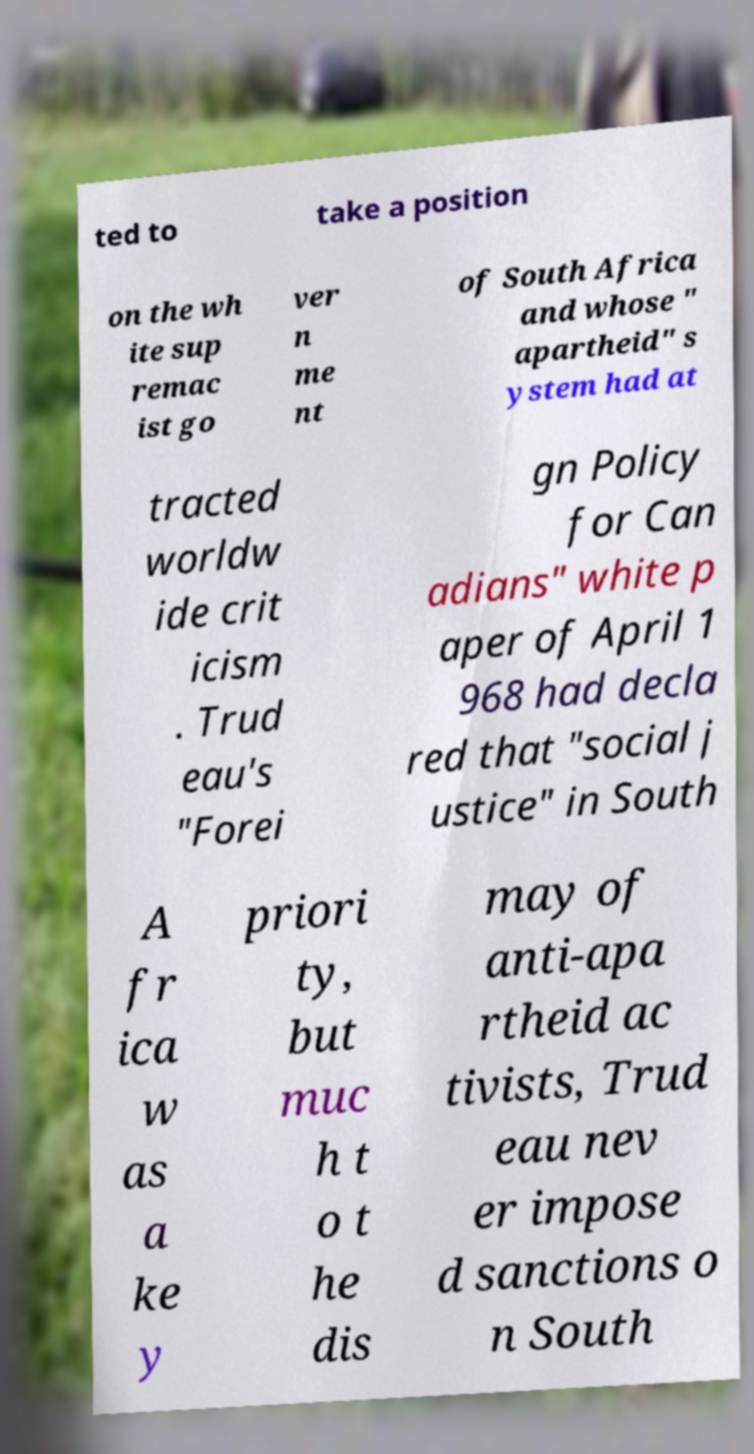Can you read and provide the text displayed in the image?This photo seems to have some interesting text. Can you extract and type it out for me? ted to take a position on the wh ite sup remac ist go ver n me nt of South Africa and whose " apartheid" s ystem had at tracted worldw ide crit icism . Trud eau's "Forei gn Policy for Can adians" white p aper of April 1 968 had decla red that "social j ustice" in South A fr ica w as a ke y priori ty, but muc h t o t he dis may of anti-apa rtheid ac tivists, Trud eau nev er impose d sanctions o n South 